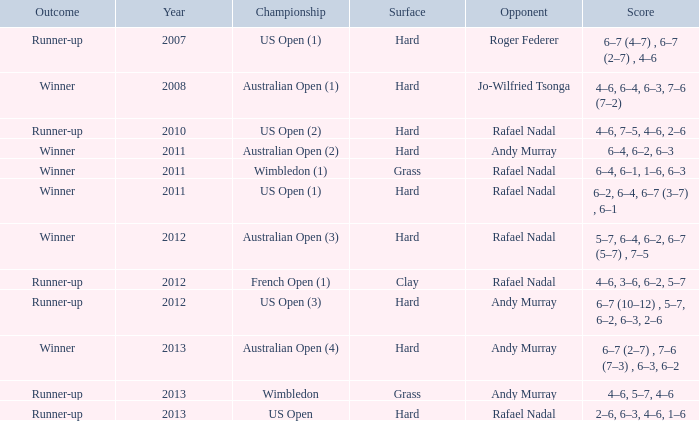What surface was the Australian Open (1) played on? Hard. 